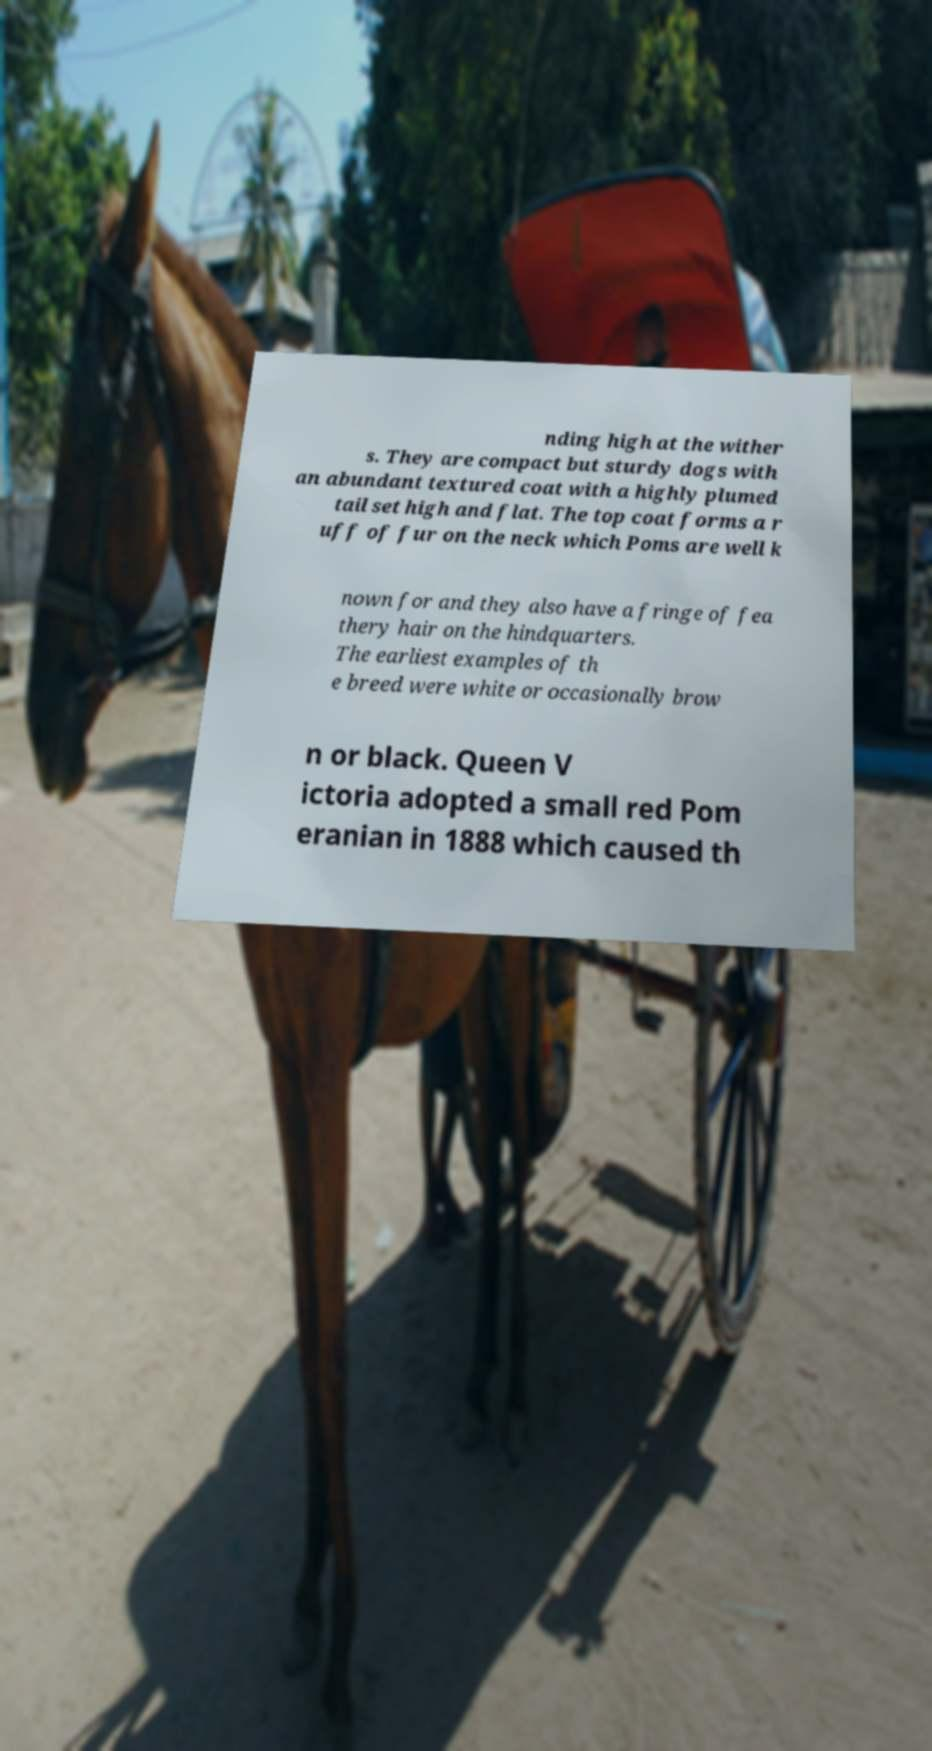Please identify and transcribe the text found in this image. nding high at the wither s. They are compact but sturdy dogs with an abundant textured coat with a highly plumed tail set high and flat. The top coat forms a r uff of fur on the neck which Poms are well k nown for and they also have a fringe of fea thery hair on the hindquarters. The earliest examples of th e breed were white or occasionally brow n or black. Queen V ictoria adopted a small red Pom eranian in 1888 which caused th 